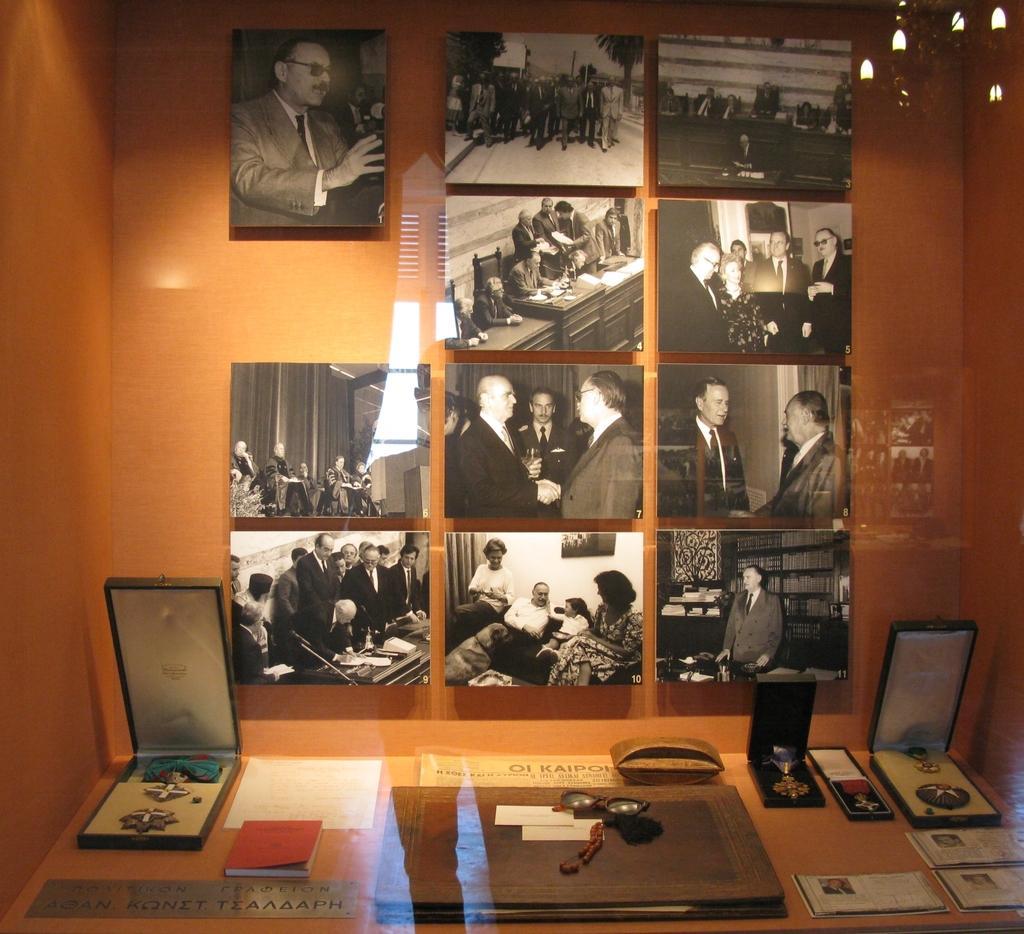Can you describe this image briefly? This picture is clicked inside the room. In the foreground we can see a table on the top of which boxes containing some items and a book and some other objects are placed. In the background we can see the wall on which we can see the pictures of group of persons and pictures of many other objects are attached. In the top right corner we can see the reflection of a chandelier and we can see the reflection of some other objects on the glass and in the center we can see the reflection of a person. 